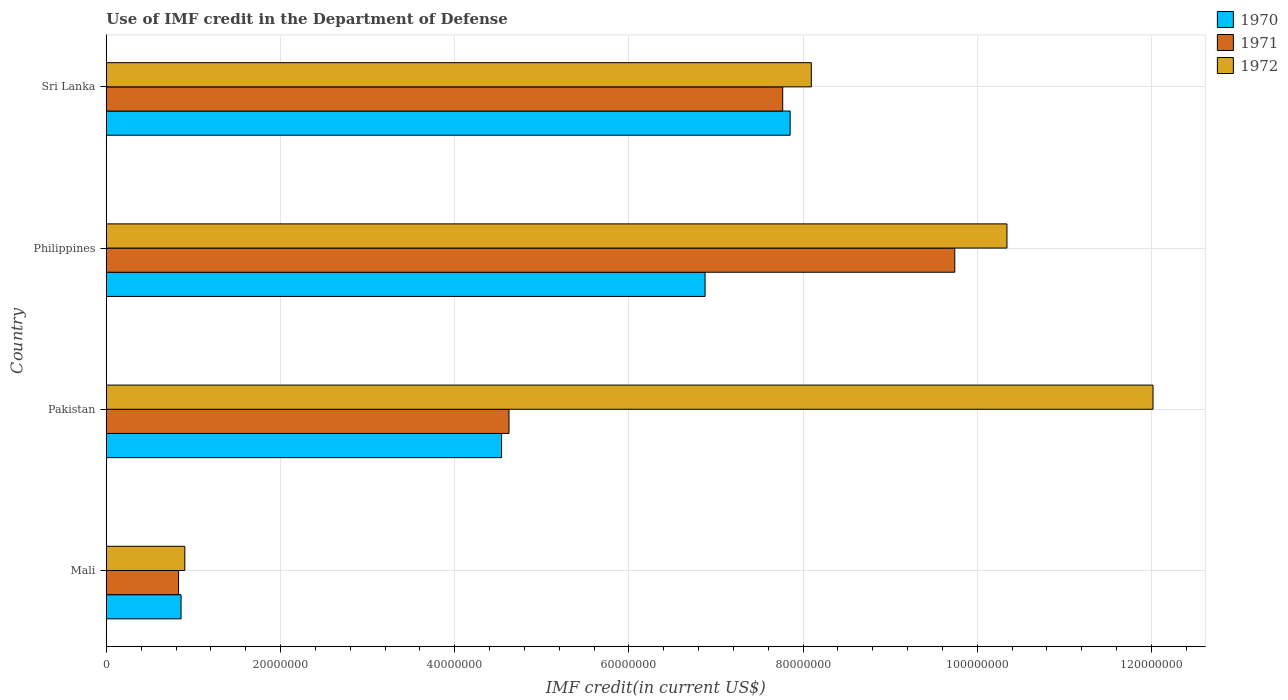How many different coloured bars are there?
Your answer should be compact. 3. How many groups of bars are there?
Make the answer very short. 4. Are the number of bars on each tick of the Y-axis equal?
Offer a very short reply. Yes. What is the IMF credit in the Department of Defense in 1970 in Mali?
Ensure brevity in your answer.  8.58e+06. Across all countries, what is the maximum IMF credit in the Department of Defense in 1970?
Ensure brevity in your answer.  7.85e+07. Across all countries, what is the minimum IMF credit in the Department of Defense in 1972?
Give a very brief answer. 9.01e+06. In which country was the IMF credit in the Department of Defense in 1971 minimum?
Give a very brief answer. Mali. What is the total IMF credit in the Department of Defense in 1972 in the graph?
Your answer should be compact. 3.14e+08. What is the difference between the IMF credit in the Department of Defense in 1971 in Pakistan and that in Philippines?
Offer a terse response. -5.12e+07. What is the difference between the IMF credit in the Department of Defense in 1970 in Pakistan and the IMF credit in the Department of Defense in 1971 in Mali?
Your response must be concise. 3.71e+07. What is the average IMF credit in the Department of Defense in 1970 per country?
Your response must be concise. 5.03e+07. What is the difference between the IMF credit in the Department of Defense in 1971 and IMF credit in the Department of Defense in 1970 in Sri Lanka?
Provide a succinct answer. -8.56e+05. In how many countries, is the IMF credit in the Department of Defense in 1972 greater than 88000000 US$?
Your response must be concise. 2. What is the ratio of the IMF credit in the Department of Defense in 1972 in Pakistan to that in Sri Lanka?
Provide a succinct answer. 1.48. Is the IMF credit in the Department of Defense in 1970 in Pakistan less than that in Sri Lanka?
Make the answer very short. Yes. Is the difference between the IMF credit in the Department of Defense in 1971 in Mali and Sri Lanka greater than the difference between the IMF credit in the Department of Defense in 1970 in Mali and Sri Lanka?
Your answer should be very brief. Yes. What is the difference between the highest and the second highest IMF credit in the Department of Defense in 1970?
Keep it short and to the point. 9.77e+06. What is the difference between the highest and the lowest IMF credit in the Department of Defense in 1970?
Ensure brevity in your answer.  6.99e+07. Is the sum of the IMF credit in the Department of Defense in 1972 in Mali and Sri Lanka greater than the maximum IMF credit in the Department of Defense in 1971 across all countries?
Your response must be concise. No. What does the 2nd bar from the top in Pakistan represents?
Your response must be concise. 1971. What does the 1st bar from the bottom in Pakistan represents?
Provide a short and direct response. 1970. How many countries are there in the graph?
Give a very brief answer. 4. Where does the legend appear in the graph?
Your answer should be very brief. Top right. What is the title of the graph?
Provide a succinct answer. Use of IMF credit in the Department of Defense. What is the label or title of the X-axis?
Provide a short and direct response. IMF credit(in current US$). What is the IMF credit(in current US$) of 1970 in Mali?
Provide a succinct answer. 8.58e+06. What is the IMF credit(in current US$) of 1971 in Mali?
Keep it short and to the point. 8.30e+06. What is the IMF credit(in current US$) in 1972 in Mali?
Offer a very short reply. 9.01e+06. What is the IMF credit(in current US$) in 1970 in Pakistan?
Provide a short and direct response. 4.54e+07. What is the IMF credit(in current US$) in 1971 in Pakistan?
Provide a succinct answer. 4.62e+07. What is the IMF credit(in current US$) in 1972 in Pakistan?
Your answer should be compact. 1.20e+08. What is the IMF credit(in current US$) of 1970 in Philippines?
Offer a very short reply. 6.88e+07. What is the IMF credit(in current US$) of 1971 in Philippines?
Make the answer very short. 9.74e+07. What is the IMF credit(in current US$) in 1972 in Philippines?
Your answer should be very brief. 1.03e+08. What is the IMF credit(in current US$) of 1970 in Sri Lanka?
Offer a terse response. 7.85e+07. What is the IMF credit(in current US$) in 1971 in Sri Lanka?
Your answer should be very brief. 7.77e+07. What is the IMF credit(in current US$) in 1972 in Sri Lanka?
Offer a terse response. 8.10e+07. Across all countries, what is the maximum IMF credit(in current US$) of 1970?
Offer a terse response. 7.85e+07. Across all countries, what is the maximum IMF credit(in current US$) in 1971?
Ensure brevity in your answer.  9.74e+07. Across all countries, what is the maximum IMF credit(in current US$) of 1972?
Keep it short and to the point. 1.20e+08. Across all countries, what is the minimum IMF credit(in current US$) of 1970?
Your answer should be compact. 8.58e+06. Across all countries, what is the minimum IMF credit(in current US$) of 1971?
Your answer should be compact. 8.30e+06. Across all countries, what is the minimum IMF credit(in current US$) in 1972?
Provide a short and direct response. 9.01e+06. What is the total IMF credit(in current US$) in 1970 in the graph?
Make the answer very short. 2.01e+08. What is the total IMF credit(in current US$) of 1971 in the graph?
Give a very brief answer. 2.30e+08. What is the total IMF credit(in current US$) of 1972 in the graph?
Provide a short and direct response. 3.14e+08. What is the difference between the IMF credit(in current US$) in 1970 in Mali and that in Pakistan?
Provide a succinct answer. -3.68e+07. What is the difference between the IMF credit(in current US$) in 1971 in Mali and that in Pakistan?
Ensure brevity in your answer.  -3.79e+07. What is the difference between the IMF credit(in current US$) of 1972 in Mali and that in Pakistan?
Provide a short and direct response. -1.11e+08. What is the difference between the IMF credit(in current US$) of 1970 in Mali and that in Philippines?
Provide a succinct answer. -6.02e+07. What is the difference between the IMF credit(in current US$) in 1971 in Mali and that in Philippines?
Make the answer very short. -8.91e+07. What is the difference between the IMF credit(in current US$) in 1972 in Mali and that in Philippines?
Provide a short and direct response. -9.44e+07. What is the difference between the IMF credit(in current US$) in 1970 in Mali and that in Sri Lanka?
Offer a very short reply. -6.99e+07. What is the difference between the IMF credit(in current US$) of 1971 in Mali and that in Sri Lanka?
Provide a short and direct response. -6.94e+07. What is the difference between the IMF credit(in current US$) in 1972 in Mali and that in Sri Lanka?
Provide a short and direct response. -7.19e+07. What is the difference between the IMF credit(in current US$) of 1970 in Pakistan and that in Philippines?
Your answer should be compact. -2.34e+07. What is the difference between the IMF credit(in current US$) in 1971 in Pakistan and that in Philippines?
Make the answer very short. -5.12e+07. What is the difference between the IMF credit(in current US$) in 1972 in Pakistan and that in Philippines?
Your response must be concise. 1.68e+07. What is the difference between the IMF credit(in current US$) in 1970 in Pakistan and that in Sri Lanka?
Keep it short and to the point. -3.31e+07. What is the difference between the IMF credit(in current US$) in 1971 in Pakistan and that in Sri Lanka?
Give a very brief answer. -3.14e+07. What is the difference between the IMF credit(in current US$) in 1972 in Pakistan and that in Sri Lanka?
Ensure brevity in your answer.  3.92e+07. What is the difference between the IMF credit(in current US$) of 1970 in Philippines and that in Sri Lanka?
Your answer should be very brief. -9.77e+06. What is the difference between the IMF credit(in current US$) in 1971 in Philippines and that in Sri Lanka?
Your response must be concise. 1.98e+07. What is the difference between the IMF credit(in current US$) of 1972 in Philippines and that in Sri Lanka?
Your answer should be very brief. 2.25e+07. What is the difference between the IMF credit(in current US$) in 1970 in Mali and the IMF credit(in current US$) in 1971 in Pakistan?
Give a very brief answer. -3.77e+07. What is the difference between the IMF credit(in current US$) of 1970 in Mali and the IMF credit(in current US$) of 1972 in Pakistan?
Offer a very short reply. -1.12e+08. What is the difference between the IMF credit(in current US$) in 1971 in Mali and the IMF credit(in current US$) in 1972 in Pakistan?
Your response must be concise. -1.12e+08. What is the difference between the IMF credit(in current US$) in 1970 in Mali and the IMF credit(in current US$) in 1971 in Philippines?
Your response must be concise. -8.88e+07. What is the difference between the IMF credit(in current US$) of 1970 in Mali and the IMF credit(in current US$) of 1972 in Philippines?
Offer a terse response. -9.48e+07. What is the difference between the IMF credit(in current US$) of 1971 in Mali and the IMF credit(in current US$) of 1972 in Philippines?
Your answer should be compact. -9.51e+07. What is the difference between the IMF credit(in current US$) in 1970 in Mali and the IMF credit(in current US$) in 1971 in Sri Lanka?
Ensure brevity in your answer.  -6.91e+07. What is the difference between the IMF credit(in current US$) in 1970 in Mali and the IMF credit(in current US$) in 1972 in Sri Lanka?
Ensure brevity in your answer.  -7.24e+07. What is the difference between the IMF credit(in current US$) of 1971 in Mali and the IMF credit(in current US$) of 1972 in Sri Lanka?
Your response must be concise. -7.27e+07. What is the difference between the IMF credit(in current US$) in 1970 in Pakistan and the IMF credit(in current US$) in 1971 in Philippines?
Keep it short and to the point. -5.20e+07. What is the difference between the IMF credit(in current US$) in 1970 in Pakistan and the IMF credit(in current US$) in 1972 in Philippines?
Make the answer very short. -5.80e+07. What is the difference between the IMF credit(in current US$) of 1971 in Pakistan and the IMF credit(in current US$) of 1972 in Philippines?
Offer a terse response. -5.72e+07. What is the difference between the IMF credit(in current US$) of 1970 in Pakistan and the IMF credit(in current US$) of 1971 in Sri Lanka?
Your answer should be compact. -3.23e+07. What is the difference between the IMF credit(in current US$) of 1970 in Pakistan and the IMF credit(in current US$) of 1972 in Sri Lanka?
Make the answer very short. -3.56e+07. What is the difference between the IMF credit(in current US$) in 1971 in Pakistan and the IMF credit(in current US$) in 1972 in Sri Lanka?
Give a very brief answer. -3.47e+07. What is the difference between the IMF credit(in current US$) of 1970 in Philippines and the IMF credit(in current US$) of 1971 in Sri Lanka?
Make the answer very short. -8.91e+06. What is the difference between the IMF credit(in current US$) of 1970 in Philippines and the IMF credit(in current US$) of 1972 in Sri Lanka?
Give a very brief answer. -1.22e+07. What is the difference between the IMF credit(in current US$) of 1971 in Philippines and the IMF credit(in current US$) of 1972 in Sri Lanka?
Your response must be concise. 1.65e+07. What is the average IMF credit(in current US$) of 1970 per country?
Provide a short and direct response. 5.03e+07. What is the average IMF credit(in current US$) in 1971 per country?
Your response must be concise. 5.74e+07. What is the average IMF credit(in current US$) of 1972 per country?
Your answer should be very brief. 7.84e+07. What is the difference between the IMF credit(in current US$) of 1970 and IMF credit(in current US$) of 1971 in Mali?
Make the answer very short. 2.85e+05. What is the difference between the IMF credit(in current US$) of 1970 and IMF credit(in current US$) of 1972 in Mali?
Ensure brevity in your answer.  -4.31e+05. What is the difference between the IMF credit(in current US$) of 1971 and IMF credit(in current US$) of 1972 in Mali?
Make the answer very short. -7.16e+05. What is the difference between the IMF credit(in current US$) in 1970 and IMF credit(in current US$) in 1971 in Pakistan?
Provide a succinct answer. -8.56e+05. What is the difference between the IMF credit(in current US$) of 1970 and IMF credit(in current US$) of 1972 in Pakistan?
Offer a terse response. -7.48e+07. What is the difference between the IMF credit(in current US$) in 1971 and IMF credit(in current US$) in 1972 in Pakistan?
Ensure brevity in your answer.  -7.40e+07. What is the difference between the IMF credit(in current US$) of 1970 and IMF credit(in current US$) of 1971 in Philippines?
Offer a terse response. -2.87e+07. What is the difference between the IMF credit(in current US$) in 1970 and IMF credit(in current US$) in 1972 in Philippines?
Offer a very short reply. -3.47e+07. What is the difference between the IMF credit(in current US$) in 1971 and IMF credit(in current US$) in 1972 in Philippines?
Your answer should be compact. -5.99e+06. What is the difference between the IMF credit(in current US$) in 1970 and IMF credit(in current US$) in 1971 in Sri Lanka?
Keep it short and to the point. 8.56e+05. What is the difference between the IMF credit(in current US$) in 1970 and IMF credit(in current US$) in 1972 in Sri Lanka?
Give a very brief answer. -2.43e+06. What is the difference between the IMF credit(in current US$) in 1971 and IMF credit(in current US$) in 1972 in Sri Lanka?
Make the answer very short. -3.29e+06. What is the ratio of the IMF credit(in current US$) of 1970 in Mali to that in Pakistan?
Offer a terse response. 0.19. What is the ratio of the IMF credit(in current US$) in 1971 in Mali to that in Pakistan?
Offer a very short reply. 0.18. What is the ratio of the IMF credit(in current US$) of 1972 in Mali to that in Pakistan?
Provide a short and direct response. 0.07. What is the ratio of the IMF credit(in current US$) in 1970 in Mali to that in Philippines?
Make the answer very short. 0.12. What is the ratio of the IMF credit(in current US$) of 1971 in Mali to that in Philippines?
Your response must be concise. 0.09. What is the ratio of the IMF credit(in current US$) in 1972 in Mali to that in Philippines?
Give a very brief answer. 0.09. What is the ratio of the IMF credit(in current US$) of 1970 in Mali to that in Sri Lanka?
Make the answer very short. 0.11. What is the ratio of the IMF credit(in current US$) of 1971 in Mali to that in Sri Lanka?
Ensure brevity in your answer.  0.11. What is the ratio of the IMF credit(in current US$) in 1972 in Mali to that in Sri Lanka?
Give a very brief answer. 0.11. What is the ratio of the IMF credit(in current US$) of 1970 in Pakistan to that in Philippines?
Give a very brief answer. 0.66. What is the ratio of the IMF credit(in current US$) of 1971 in Pakistan to that in Philippines?
Make the answer very short. 0.47. What is the ratio of the IMF credit(in current US$) in 1972 in Pakistan to that in Philippines?
Provide a succinct answer. 1.16. What is the ratio of the IMF credit(in current US$) in 1970 in Pakistan to that in Sri Lanka?
Provide a short and direct response. 0.58. What is the ratio of the IMF credit(in current US$) in 1971 in Pakistan to that in Sri Lanka?
Provide a short and direct response. 0.6. What is the ratio of the IMF credit(in current US$) in 1972 in Pakistan to that in Sri Lanka?
Provide a short and direct response. 1.48. What is the ratio of the IMF credit(in current US$) in 1970 in Philippines to that in Sri Lanka?
Your answer should be compact. 0.88. What is the ratio of the IMF credit(in current US$) in 1971 in Philippines to that in Sri Lanka?
Give a very brief answer. 1.25. What is the ratio of the IMF credit(in current US$) in 1972 in Philippines to that in Sri Lanka?
Your response must be concise. 1.28. What is the difference between the highest and the second highest IMF credit(in current US$) in 1970?
Make the answer very short. 9.77e+06. What is the difference between the highest and the second highest IMF credit(in current US$) of 1971?
Your answer should be very brief. 1.98e+07. What is the difference between the highest and the second highest IMF credit(in current US$) in 1972?
Offer a very short reply. 1.68e+07. What is the difference between the highest and the lowest IMF credit(in current US$) in 1970?
Offer a terse response. 6.99e+07. What is the difference between the highest and the lowest IMF credit(in current US$) in 1971?
Your response must be concise. 8.91e+07. What is the difference between the highest and the lowest IMF credit(in current US$) in 1972?
Your response must be concise. 1.11e+08. 